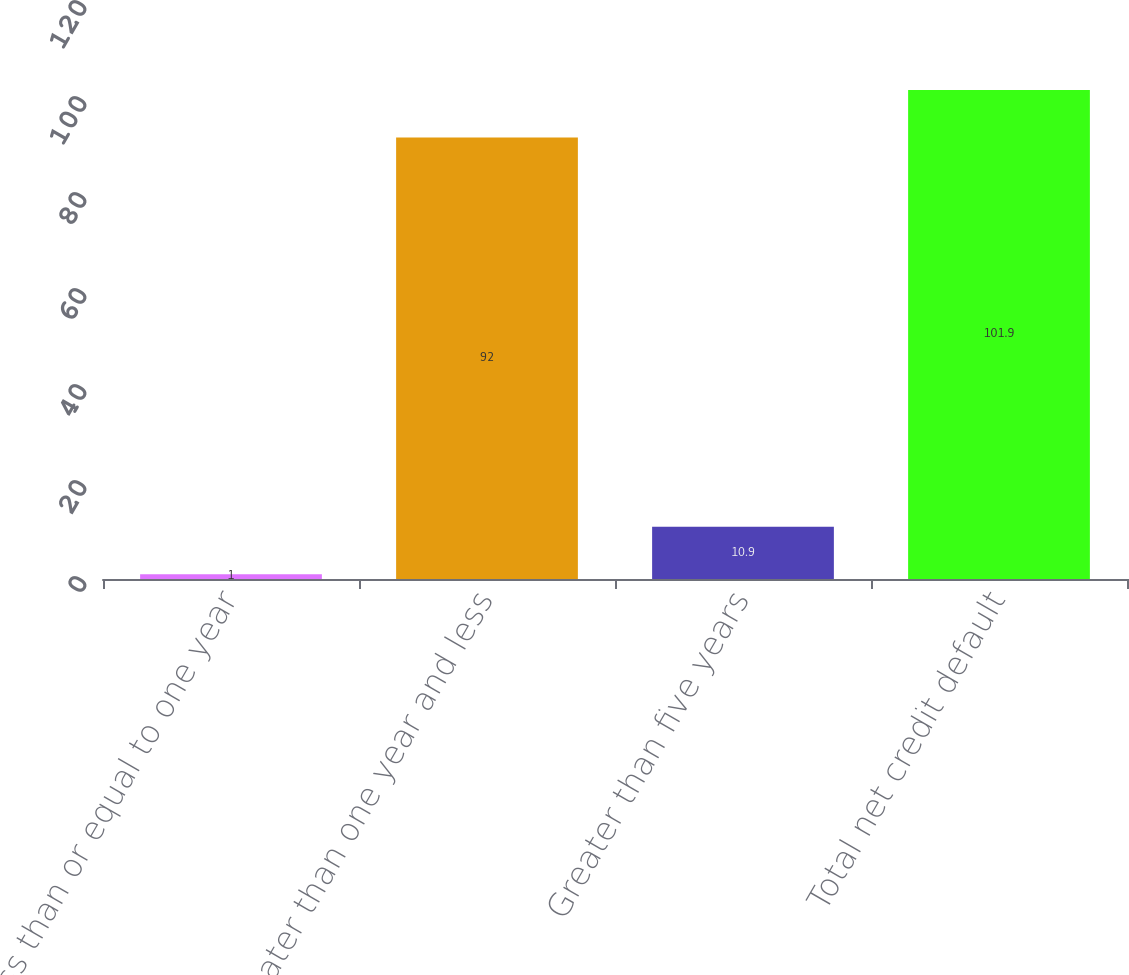Convert chart to OTSL. <chart><loc_0><loc_0><loc_500><loc_500><bar_chart><fcel>Less than or equal to one year<fcel>Greater than one year and less<fcel>Greater than five years<fcel>Total net credit default<nl><fcel>1<fcel>92<fcel>10.9<fcel>101.9<nl></chart> 